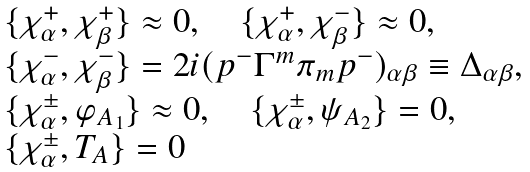Convert formula to latex. <formula><loc_0><loc_0><loc_500><loc_500>\begin{array} { l } \{ \chi ^ { + } _ { \alpha } , \chi ^ { + } _ { \beta } \} \approx 0 , \quad \{ \chi ^ { + } _ { \alpha } , \chi ^ { - } _ { \beta } \} \approx 0 , \\ \{ \chi ^ { - } _ { \alpha } , \chi ^ { - } _ { \beta } \} = 2 i ( p ^ { - } \Gamma ^ { m } \pi _ { m } p ^ { - } ) _ { \alpha \beta } \equiv \Delta _ { \alpha \beta } , \\ \{ \chi ^ { \pm } _ { \alpha } , \varphi _ { A _ { 1 } } \} \approx 0 , \quad \{ \chi ^ { \pm } _ { \alpha } , \psi _ { A _ { 2 } } \} = 0 , \\ \{ \chi ^ { \pm } _ { \alpha } , T _ { A } \} = 0 \end{array}</formula> 